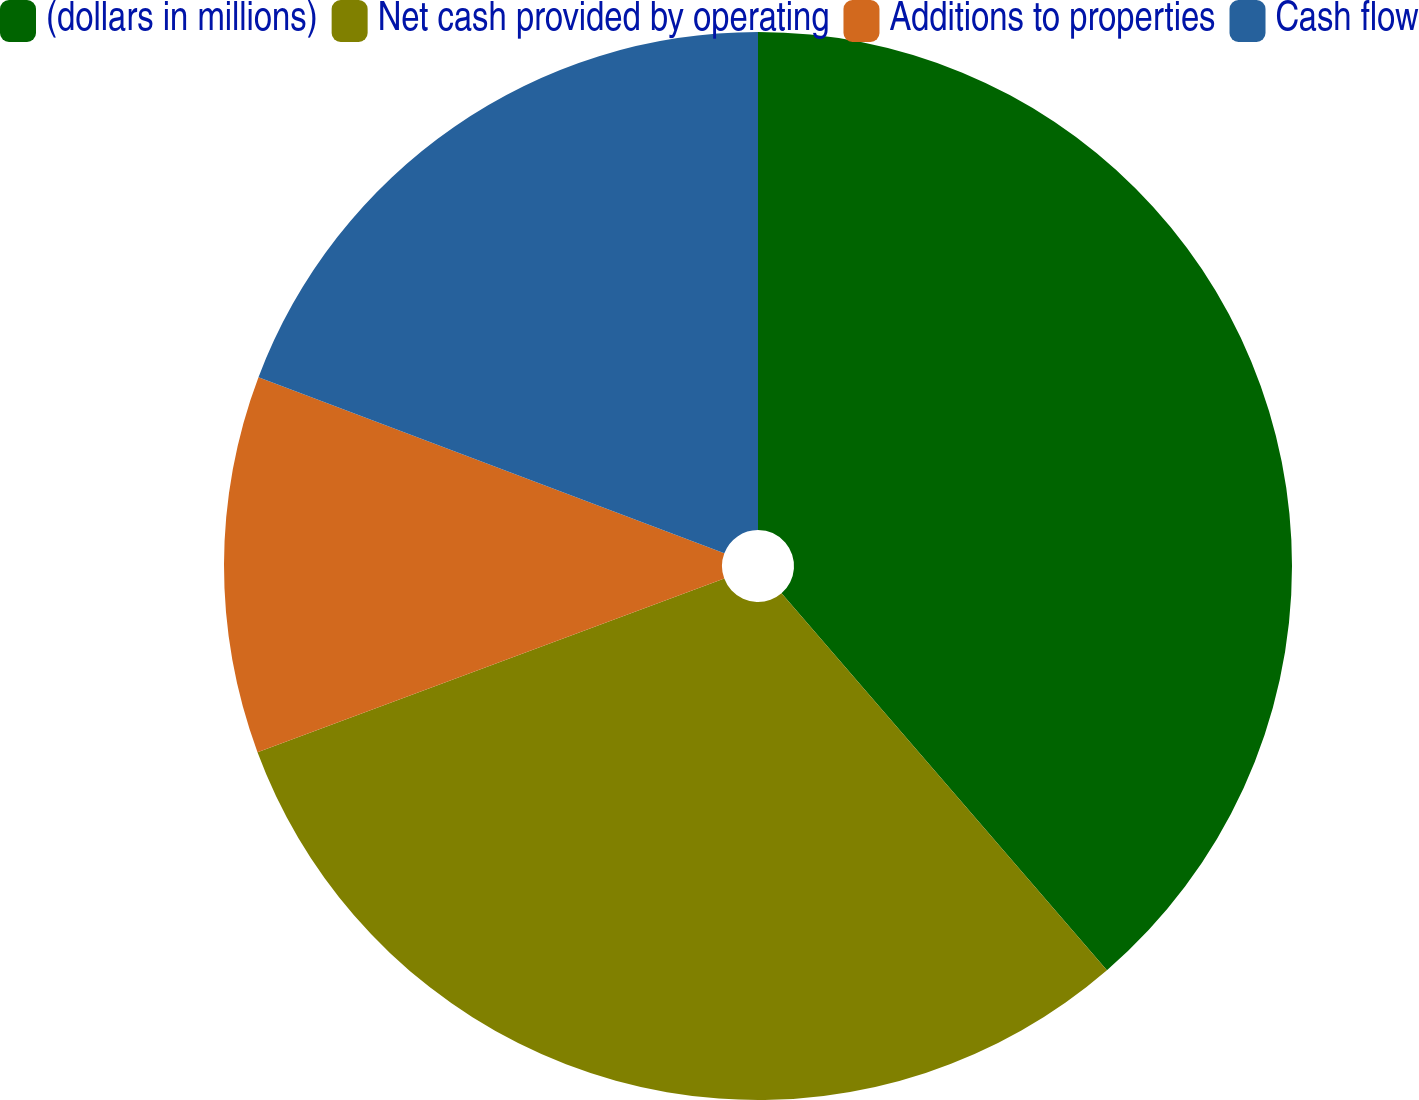Convert chart. <chart><loc_0><loc_0><loc_500><loc_500><pie_chart><fcel>(dollars in millions)<fcel>Net cash provided by operating<fcel>Additions to properties<fcel>Cash flow<nl><fcel>38.67%<fcel>30.67%<fcel>11.42%<fcel>19.25%<nl></chart> 